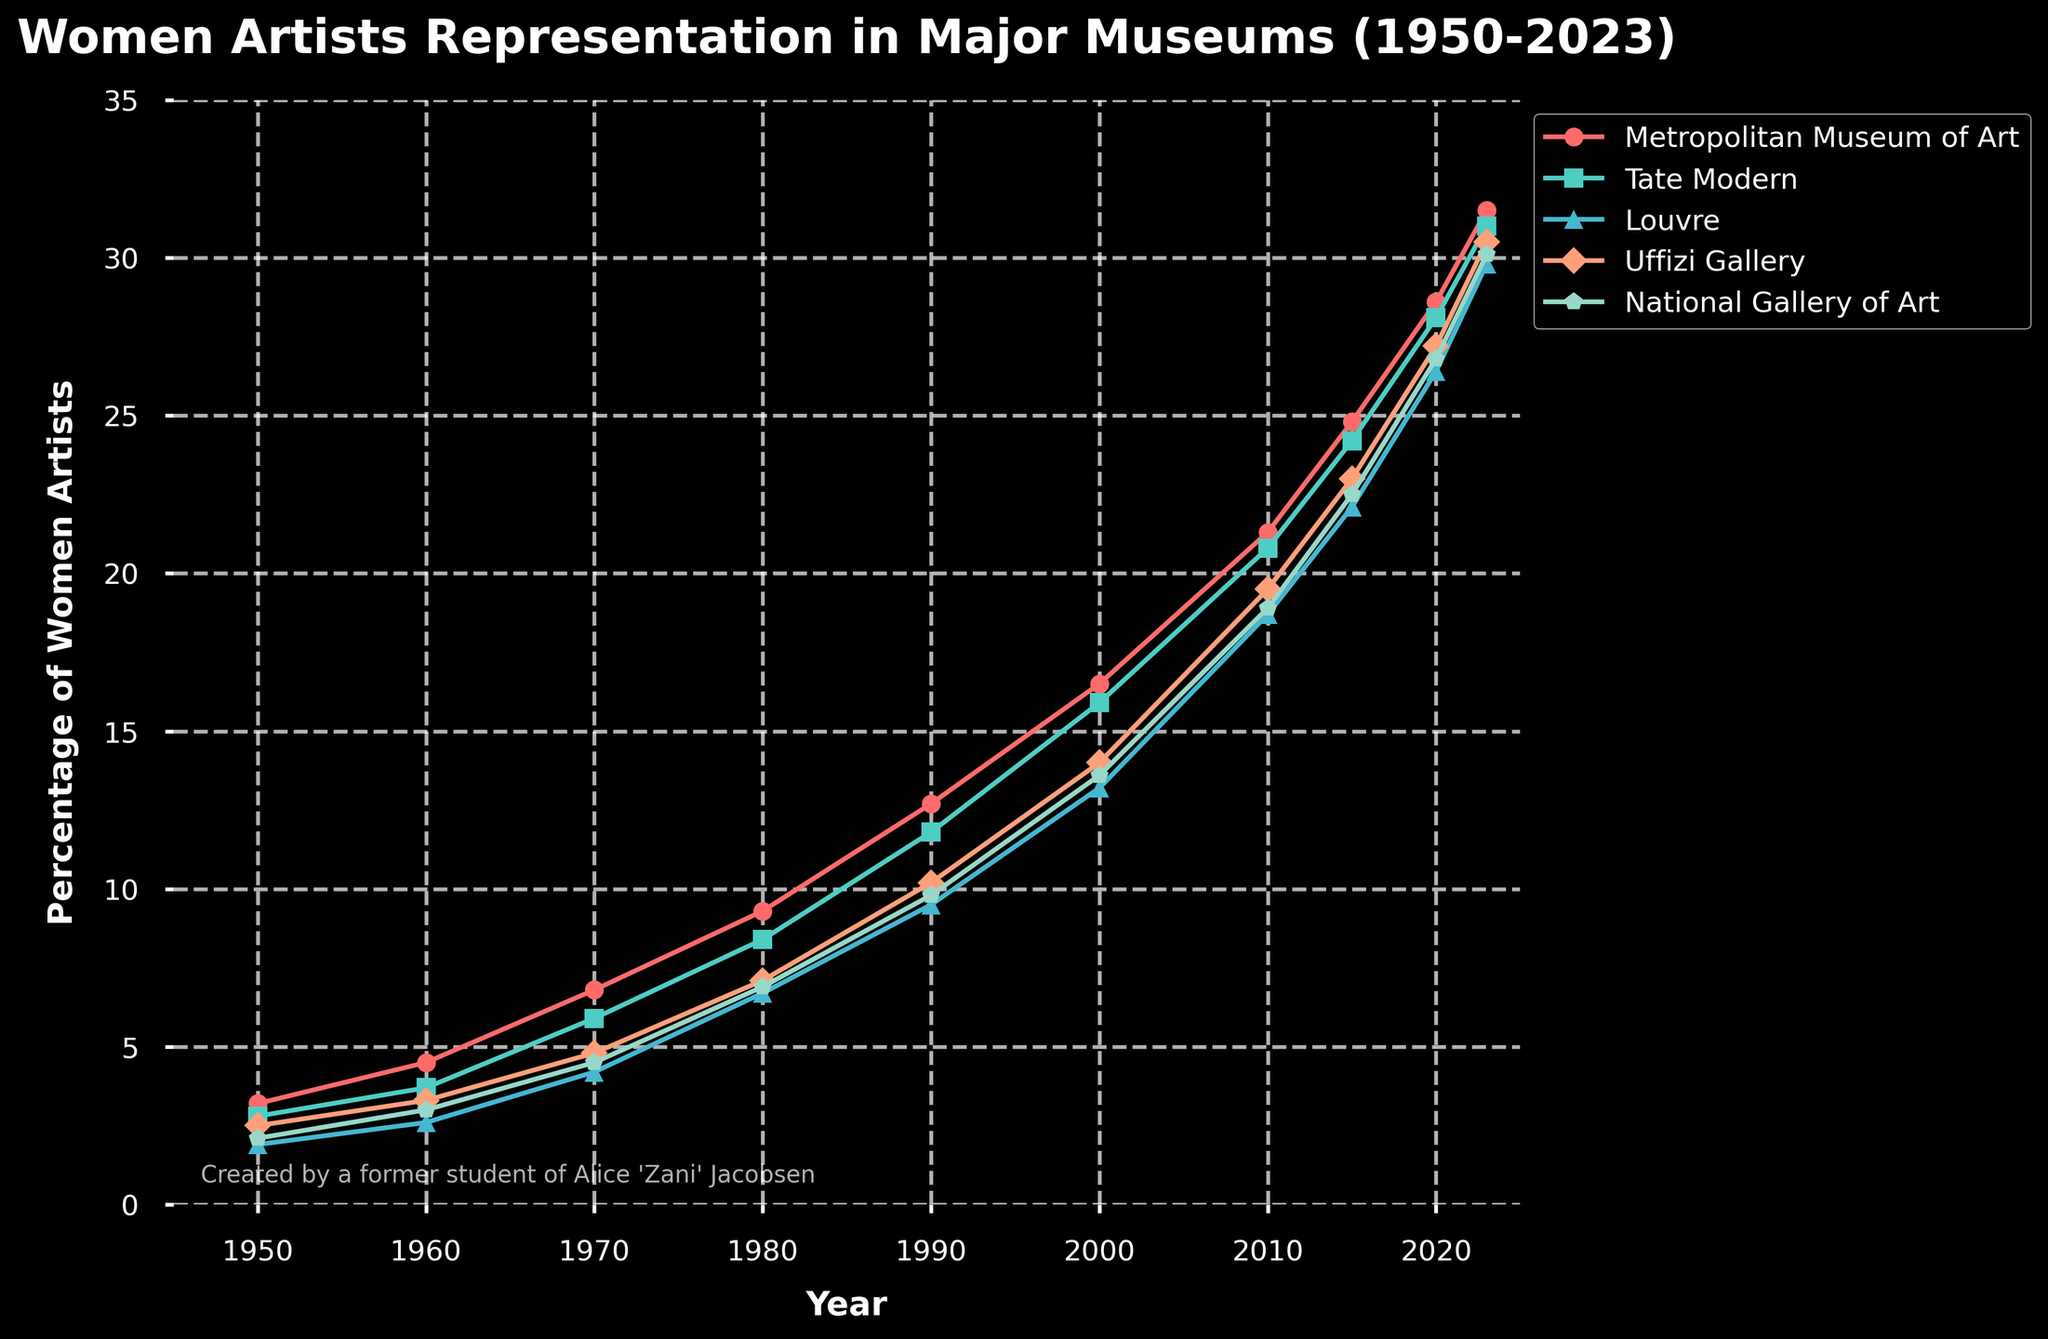What's the trend of women's representation in the Metropolitan Museum of Art from 1950 to 2023? Look at the line corresponding to the Metropolitan Museum of Art. The percentage has consistently increased from 3.2% in 1950 to 31.5% in 2023.
Answer: Increasing Which museum had the highest percentage of women artists in 1980? Identify the highest point among all the museums for the year 1980. The Metropolitan Museum of Art had the highest percentage at 9.3%.
Answer: Metropolitan Museum of Art Rate the museum which had the least increase in women's representation between 1950 and 2023. Calculate the difference for each museum between 1950 and 2023. The Louvre had an increase from 1.9% to 29.8%, which results in the least increase of 27.9%.
Answer: Louvre Which years show the most significant increase in the percentage of women artists for the Uffizi Gallery? Check the percentages of the Uffizi Gallery across all years and calculate the differences. The largest increase was from 2010 to 2015, increasing from 19.5% to 23.0%, a 3.5% rise.
Answer: 2010 to 2015 How does the representation of women artists in the Tate Modern in 2020 compare to the National Gallery of Art in 2023? Compare the points for Tate Modern in 2020 (28.1%) and National Gallery of Art in 2023 (30.1%). The National Gallery of Art in 2023 has a higher percentage.
Answer: National Gallery of Art in 2023 What is the average percentage of women artists in the Louvre over the decades listed? Sum the percentages for all decades and divide by the number of decades: (1.9 + 2.6 + 4.2 + 6.7 + 9.5 + 13.2 + 18.7 + 22.1 + 26.4 + 29.8) / 10 = 13.51%.
Answer: 13.51% What color represents the Uffizi Gallery in the chart? Identify the color of the line representing the Uffizi Gallery based on the legend. The Uffizi Gallery is represented by the orange line.
Answer: Orange Which two museums had nearly identical percentages of women artists in any given year? Identify the lines or markers that touch or nearly touch. In 1960, the Louvre (2.6%) and National Gallery of Art (3.0%) are very close.
Answer: Louvre and National Gallery of Art in 1960 Between 1990 and 2000, which museum showed the greatest improvement in women's representation? Calculate the differences between 1990 and 2000 for all museums. The Metropolitan Museum of Art improved by 16.5% - 12.7% = 3.8%, the highest increase.
Answer: Metropolitan Museum of Art 